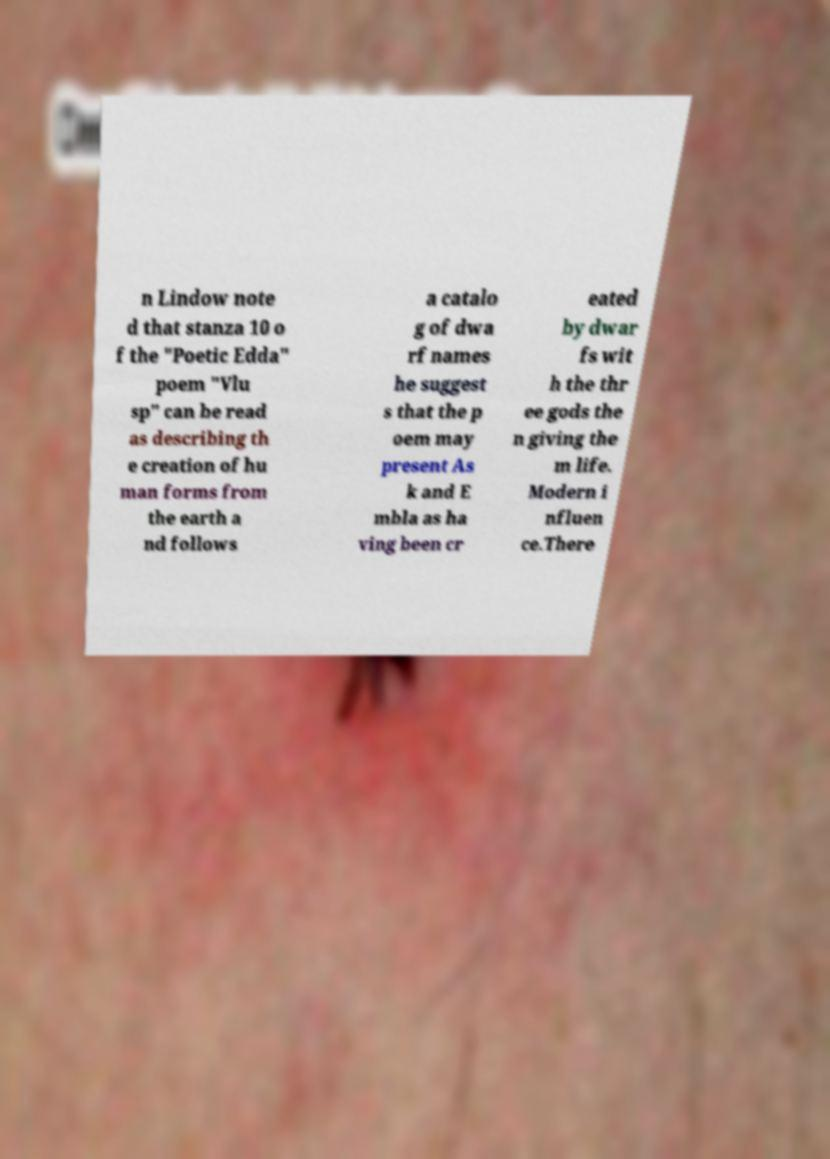I need the written content from this picture converted into text. Can you do that? n Lindow note d that stanza 10 o f the "Poetic Edda" poem "Vlu sp" can be read as describing th e creation of hu man forms from the earth a nd follows a catalo g of dwa rf names he suggest s that the p oem may present As k and E mbla as ha ving been cr eated by dwar fs wit h the thr ee gods the n giving the m life. Modern i nfluen ce.There 